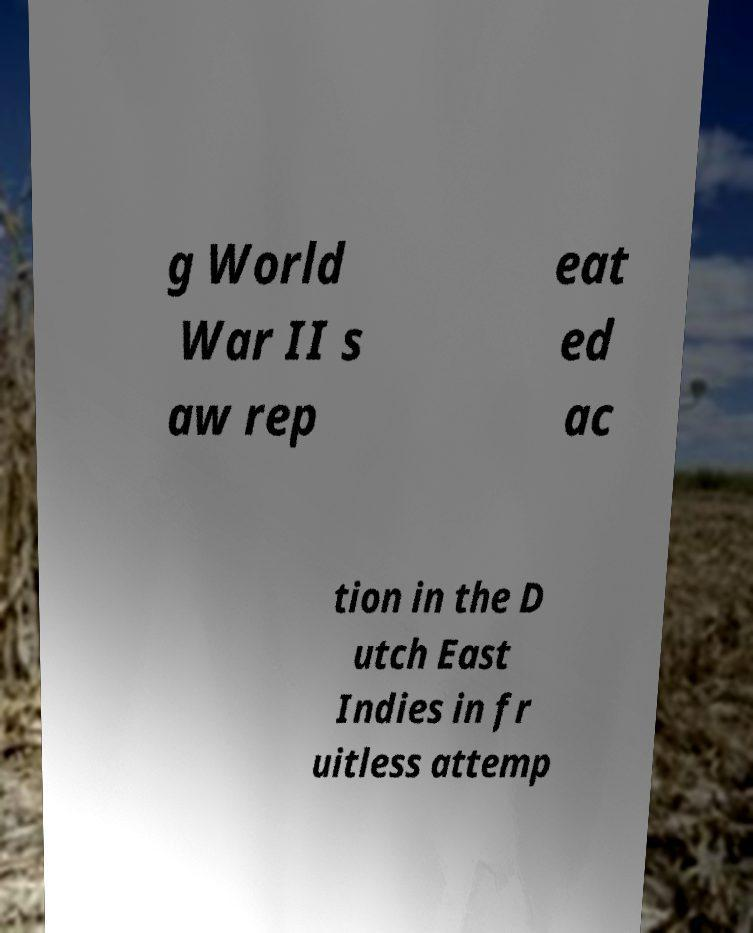Can you accurately transcribe the text from the provided image for me? g World War II s aw rep eat ed ac tion in the D utch East Indies in fr uitless attemp 